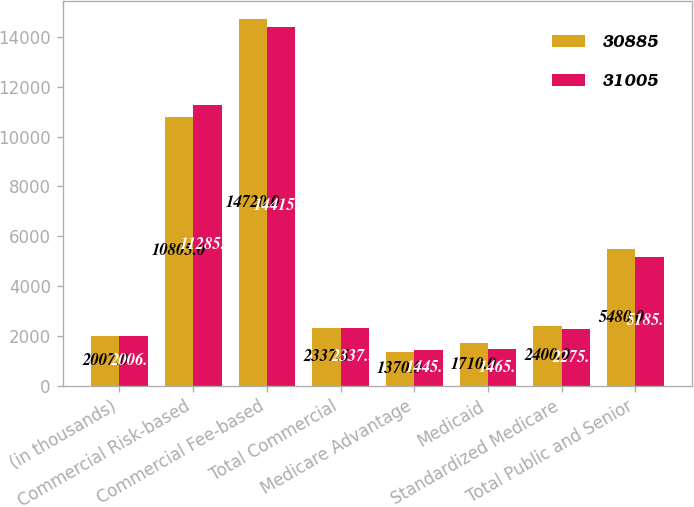Convert chart to OTSL. <chart><loc_0><loc_0><loc_500><loc_500><stacked_bar_chart><ecel><fcel>(in thousands)<fcel>Commercial Risk-based<fcel>Commercial Fee-based<fcel>Total Commercial<fcel>Medicare Advantage<fcel>Medicaid<fcel>Standardized Medicare<fcel>Total Public and Senior<nl><fcel>30885<fcel>2007<fcel>10805<fcel>14720<fcel>2337.5<fcel>1370<fcel>1710<fcel>2400<fcel>5480<nl><fcel>31005<fcel>2006<fcel>11285<fcel>14415<fcel>2337.5<fcel>1445<fcel>1465<fcel>2275<fcel>5185<nl></chart> 